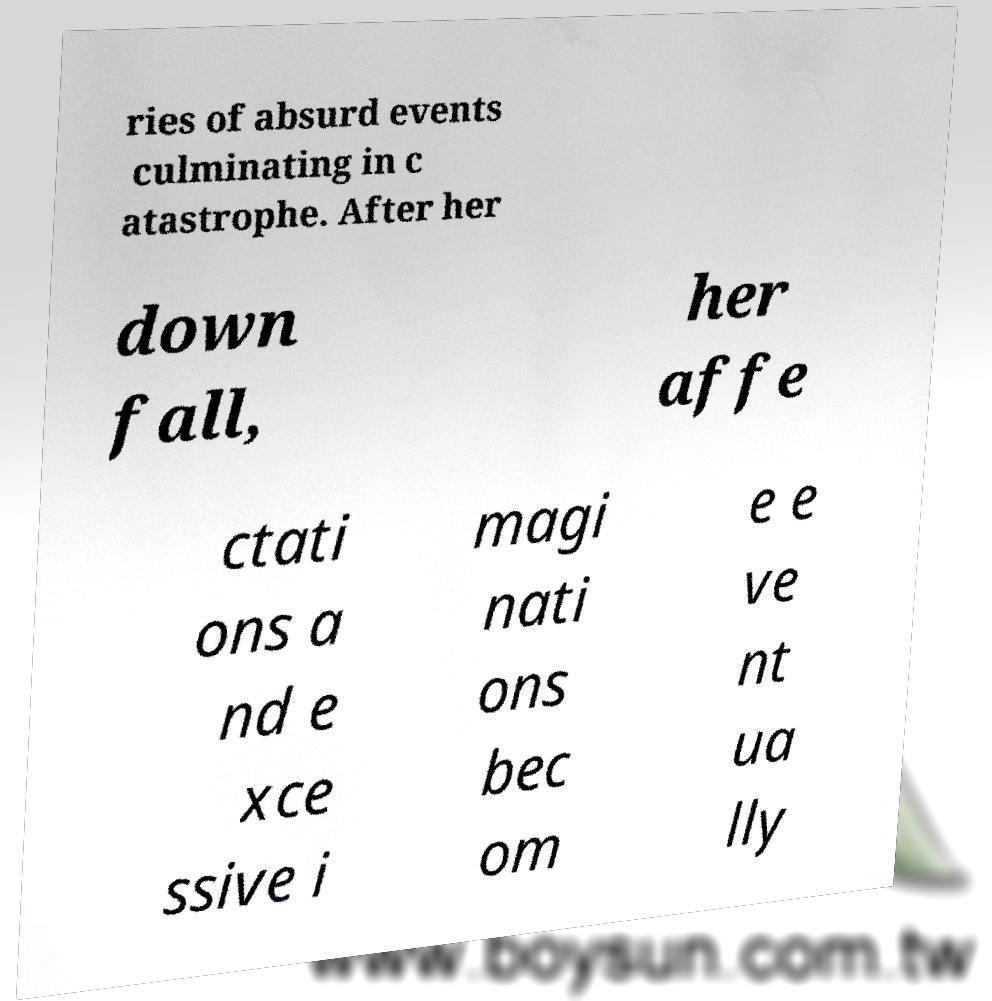What messages or text are displayed in this image? I need them in a readable, typed format. ries of absurd events culminating in c atastrophe. After her down fall, her affe ctati ons a nd e xce ssive i magi nati ons bec om e e ve nt ua lly 